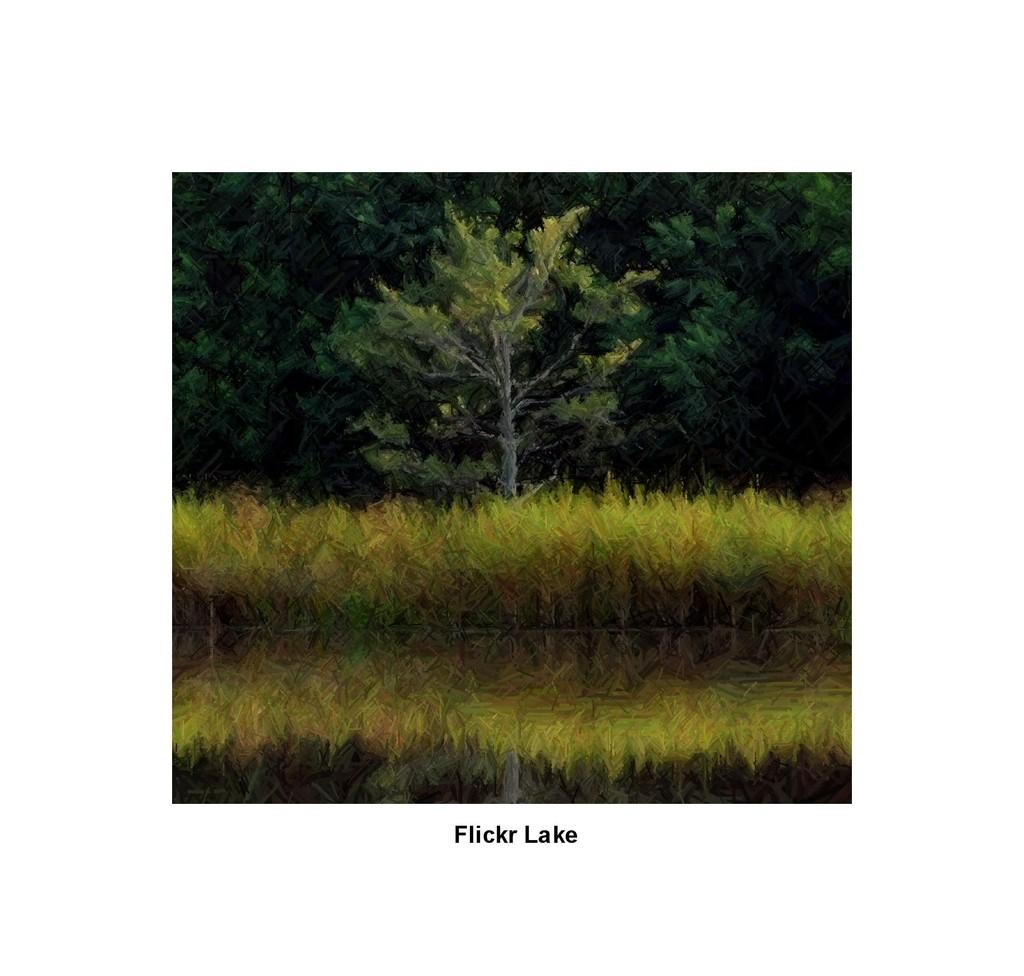What type of vegetation can be seen in the image? There is grass in the image. What other natural elements are present in the image? There are trees in the image. Is there any text visible in the image? Yes, there is text at the bottom of the image. How many trains can be seen passing through the grass in the image? There are no trains present in the image; it features grass and trees. What type of relation is depicted between the trees and the grass in the image? There is no depiction of a relation between the trees and the grass in the image; they are simply separate elements in the scene. 